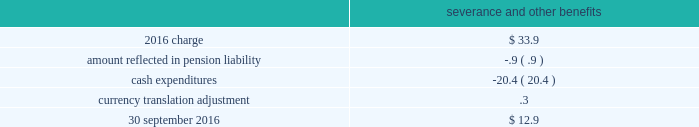As of 30 september 2016 and 2015 , there were no assets or liabilities classified as discontinued operations relating to the homecare business .
Business restructuring and cost reduction actions the charges we record for business restructuring and cost reduction actions have been excluded from segment operating income .
Cost reduction actions in fiscal year 2016 , we recognized an expense of $ 33.9 ( $ 24.0 after-tax , or $ .11 per share ) for severance and other benefits related to cost reduction actions which resulted in the elimination of approximately 700 positions .
The expenses related primarily to the industrial gases 2013 americas and the industrial gases 2013 emea segments .
The table summarizes the carrying amount of the accrual for cost reduction actions at 30 september severance and other benefits .
Business realignment and reorganization on 18 september 2014 , we announced plans to reorganize the company , including realignment of our businesses in new reporting segments and other organizational changes , effective as of 1 october 2014 .
As a result of this reorganization , we incurred severance and other charges .
In fiscal year 2015 , we recognized an expense of $ 207.7 ( $ 153.2 after-tax , or $ .71 per share ) .
Severance and other benefits totaled $ 151.9 and related to the elimination of approximately 2000 positions .
Asset and associated contract actions totaled $ 55.8 and related primarily to a plant shutdown in the corporate and other segment and the exit of product lines within the industrial gases 2013 global and materials technologies segments .
The 2015 charges related to the segments as follows : $ 31.7 in industrial gases 2013 americas , $ 52.2 in industrial gases 2013 emea , $ 10.3 in industrial gases 2013 asia , $ 37.0 in industrial gases 2013 global , $ 27.6 in materials technologies , and $ 48.9 in corporate and other .
During the fourth quarter of 2014 , an expense of $ 12.7 ( $ 8.2 after-tax , or $ .04 per share ) was incurred relating to the elimination of approximately 50 positions .
The 2014 charge related to the segments as follows : $ 2.9 in industrial gases 2013 americas , $ 3.1 in industrial gases 2013 emea , $ 1.5 in industrial gases 2013 asia , $ 1.5 in industrial gases 2013 global , $ 1.6 in materials technologies , and $ 2.1 in corporate and other. .
Considering the years 2015-2016 , what was the decrease observed in the expense for severance and other benefits? 
Rationale: it is the final value of expense for severance and other benefits minus the initial one , then divided by the initial and turned into a percentage .
Computations: ((33.9 - 207.7) / 207.7)
Answer: -0.83678. 